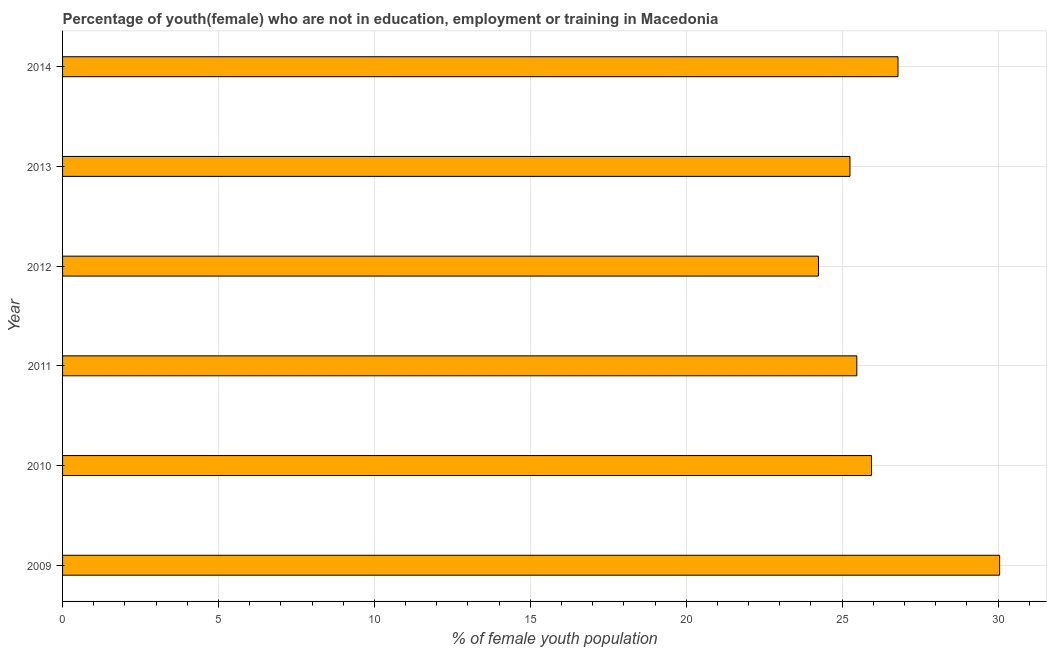What is the title of the graph?
Make the answer very short. Percentage of youth(female) who are not in education, employment or training in Macedonia. What is the label or title of the X-axis?
Provide a succinct answer. % of female youth population. What is the label or title of the Y-axis?
Make the answer very short. Year. What is the unemployed female youth population in 2010?
Give a very brief answer. 25.94. Across all years, what is the maximum unemployed female youth population?
Provide a short and direct response. 30.05. Across all years, what is the minimum unemployed female youth population?
Provide a short and direct response. 24.24. In which year was the unemployed female youth population maximum?
Provide a succinct answer. 2009. What is the sum of the unemployed female youth population?
Keep it short and to the point. 157.74. What is the difference between the unemployed female youth population in 2011 and 2012?
Your response must be concise. 1.23. What is the average unemployed female youth population per year?
Your answer should be very brief. 26.29. What is the median unemployed female youth population?
Your response must be concise. 25.7. In how many years, is the unemployed female youth population greater than 6 %?
Offer a terse response. 6. What is the ratio of the unemployed female youth population in 2009 to that in 2010?
Offer a very short reply. 1.16. What is the difference between the highest and the second highest unemployed female youth population?
Provide a short and direct response. 3.26. What is the difference between the highest and the lowest unemployed female youth population?
Your answer should be very brief. 5.81. In how many years, is the unemployed female youth population greater than the average unemployed female youth population taken over all years?
Offer a very short reply. 2. How many bars are there?
Give a very brief answer. 6. Are all the bars in the graph horizontal?
Offer a very short reply. Yes. Are the values on the major ticks of X-axis written in scientific E-notation?
Your response must be concise. No. What is the % of female youth population of 2009?
Provide a succinct answer. 30.05. What is the % of female youth population in 2010?
Ensure brevity in your answer.  25.94. What is the % of female youth population in 2011?
Give a very brief answer. 25.47. What is the % of female youth population in 2012?
Keep it short and to the point. 24.24. What is the % of female youth population in 2013?
Keep it short and to the point. 25.25. What is the % of female youth population in 2014?
Ensure brevity in your answer.  26.79. What is the difference between the % of female youth population in 2009 and 2010?
Ensure brevity in your answer.  4.11. What is the difference between the % of female youth population in 2009 and 2011?
Provide a short and direct response. 4.58. What is the difference between the % of female youth population in 2009 and 2012?
Keep it short and to the point. 5.81. What is the difference between the % of female youth population in 2009 and 2013?
Offer a very short reply. 4.8. What is the difference between the % of female youth population in 2009 and 2014?
Ensure brevity in your answer.  3.26. What is the difference between the % of female youth population in 2010 and 2011?
Make the answer very short. 0.47. What is the difference between the % of female youth population in 2010 and 2012?
Provide a succinct answer. 1.7. What is the difference between the % of female youth population in 2010 and 2013?
Give a very brief answer. 0.69. What is the difference between the % of female youth population in 2010 and 2014?
Your response must be concise. -0.85. What is the difference between the % of female youth population in 2011 and 2012?
Offer a terse response. 1.23. What is the difference between the % of female youth population in 2011 and 2013?
Your answer should be very brief. 0.22. What is the difference between the % of female youth population in 2011 and 2014?
Make the answer very short. -1.32. What is the difference between the % of female youth population in 2012 and 2013?
Ensure brevity in your answer.  -1.01. What is the difference between the % of female youth population in 2012 and 2014?
Offer a terse response. -2.55. What is the difference between the % of female youth population in 2013 and 2014?
Keep it short and to the point. -1.54. What is the ratio of the % of female youth population in 2009 to that in 2010?
Ensure brevity in your answer.  1.16. What is the ratio of the % of female youth population in 2009 to that in 2011?
Offer a terse response. 1.18. What is the ratio of the % of female youth population in 2009 to that in 2012?
Make the answer very short. 1.24. What is the ratio of the % of female youth population in 2009 to that in 2013?
Provide a succinct answer. 1.19. What is the ratio of the % of female youth population in 2009 to that in 2014?
Offer a terse response. 1.12. What is the ratio of the % of female youth population in 2010 to that in 2011?
Offer a terse response. 1.02. What is the ratio of the % of female youth population in 2010 to that in 2012?
Offer a very short reply. 1.07. What is the ratio of the % of female youth population in 2010 to that in 2013?
Give a very brief answer. 1.03. What is the ratio of the % of female youth population in 2010 to that in 2014?
Ensure brevity in your answer.  0.97. What is the ratio of the % of female youth population in 2011 to that in 2012?
Provide a succinct answer. 1.05. What is the ratio of the % of female youth population in 2011 to that in 2013?
Your response must be concise. 1.01. What is the ratio of the % of female youth population in 2011 to that in 2014?
Your answer should be very brief. 0.95. What is the ratio of the % of female youth population in 2012 to that in 2014?
Your answer should be compact. 0.91. What is the ratio of the % of female youth population in 2013 to that in 2014?
Offer a very short reply. 0.94. 